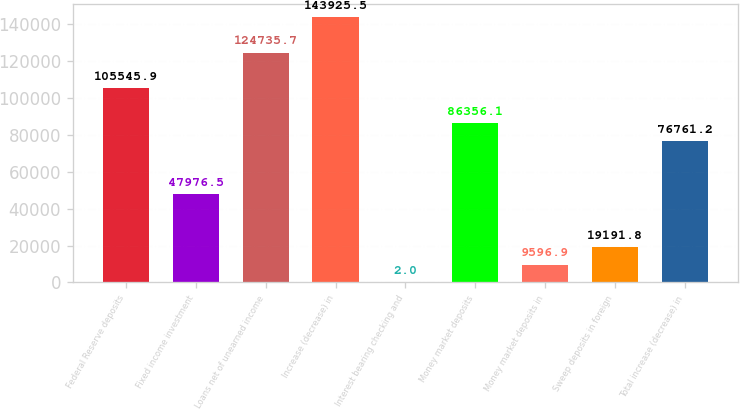Convert chart. <chart><loc_0><loc_0><loc_500><loc_500><bar_chart><fcel>Federal Reserve deposits<fcel>Fixed income investment<fcel>Loans net of unearned income<fcel>Increase (decrease) in<fcel>Interest bearing checking and<fcel>Money market deposits<fcel>Money market deposits in<fcel>Sweep deposits in foreign<fcel>Total increase (decrease) in<nl><fcel>105546<fcel>47976.5<fcel>124736<fcel>143926<fcel>2<fcel>86356.1<fcel>9596.9<fcel>19191.8<fcel>76761.2<nl></chart> 